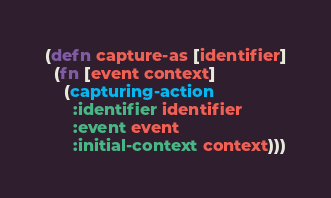<code> <loc_0><loc_0><loc_500><loc_500><_Clojure_>(defn capture-as [identifier]
  (fn [event context]
    (capturing-action
      :identifier identifier
      :event event
      :initial-context context)))
</code> 